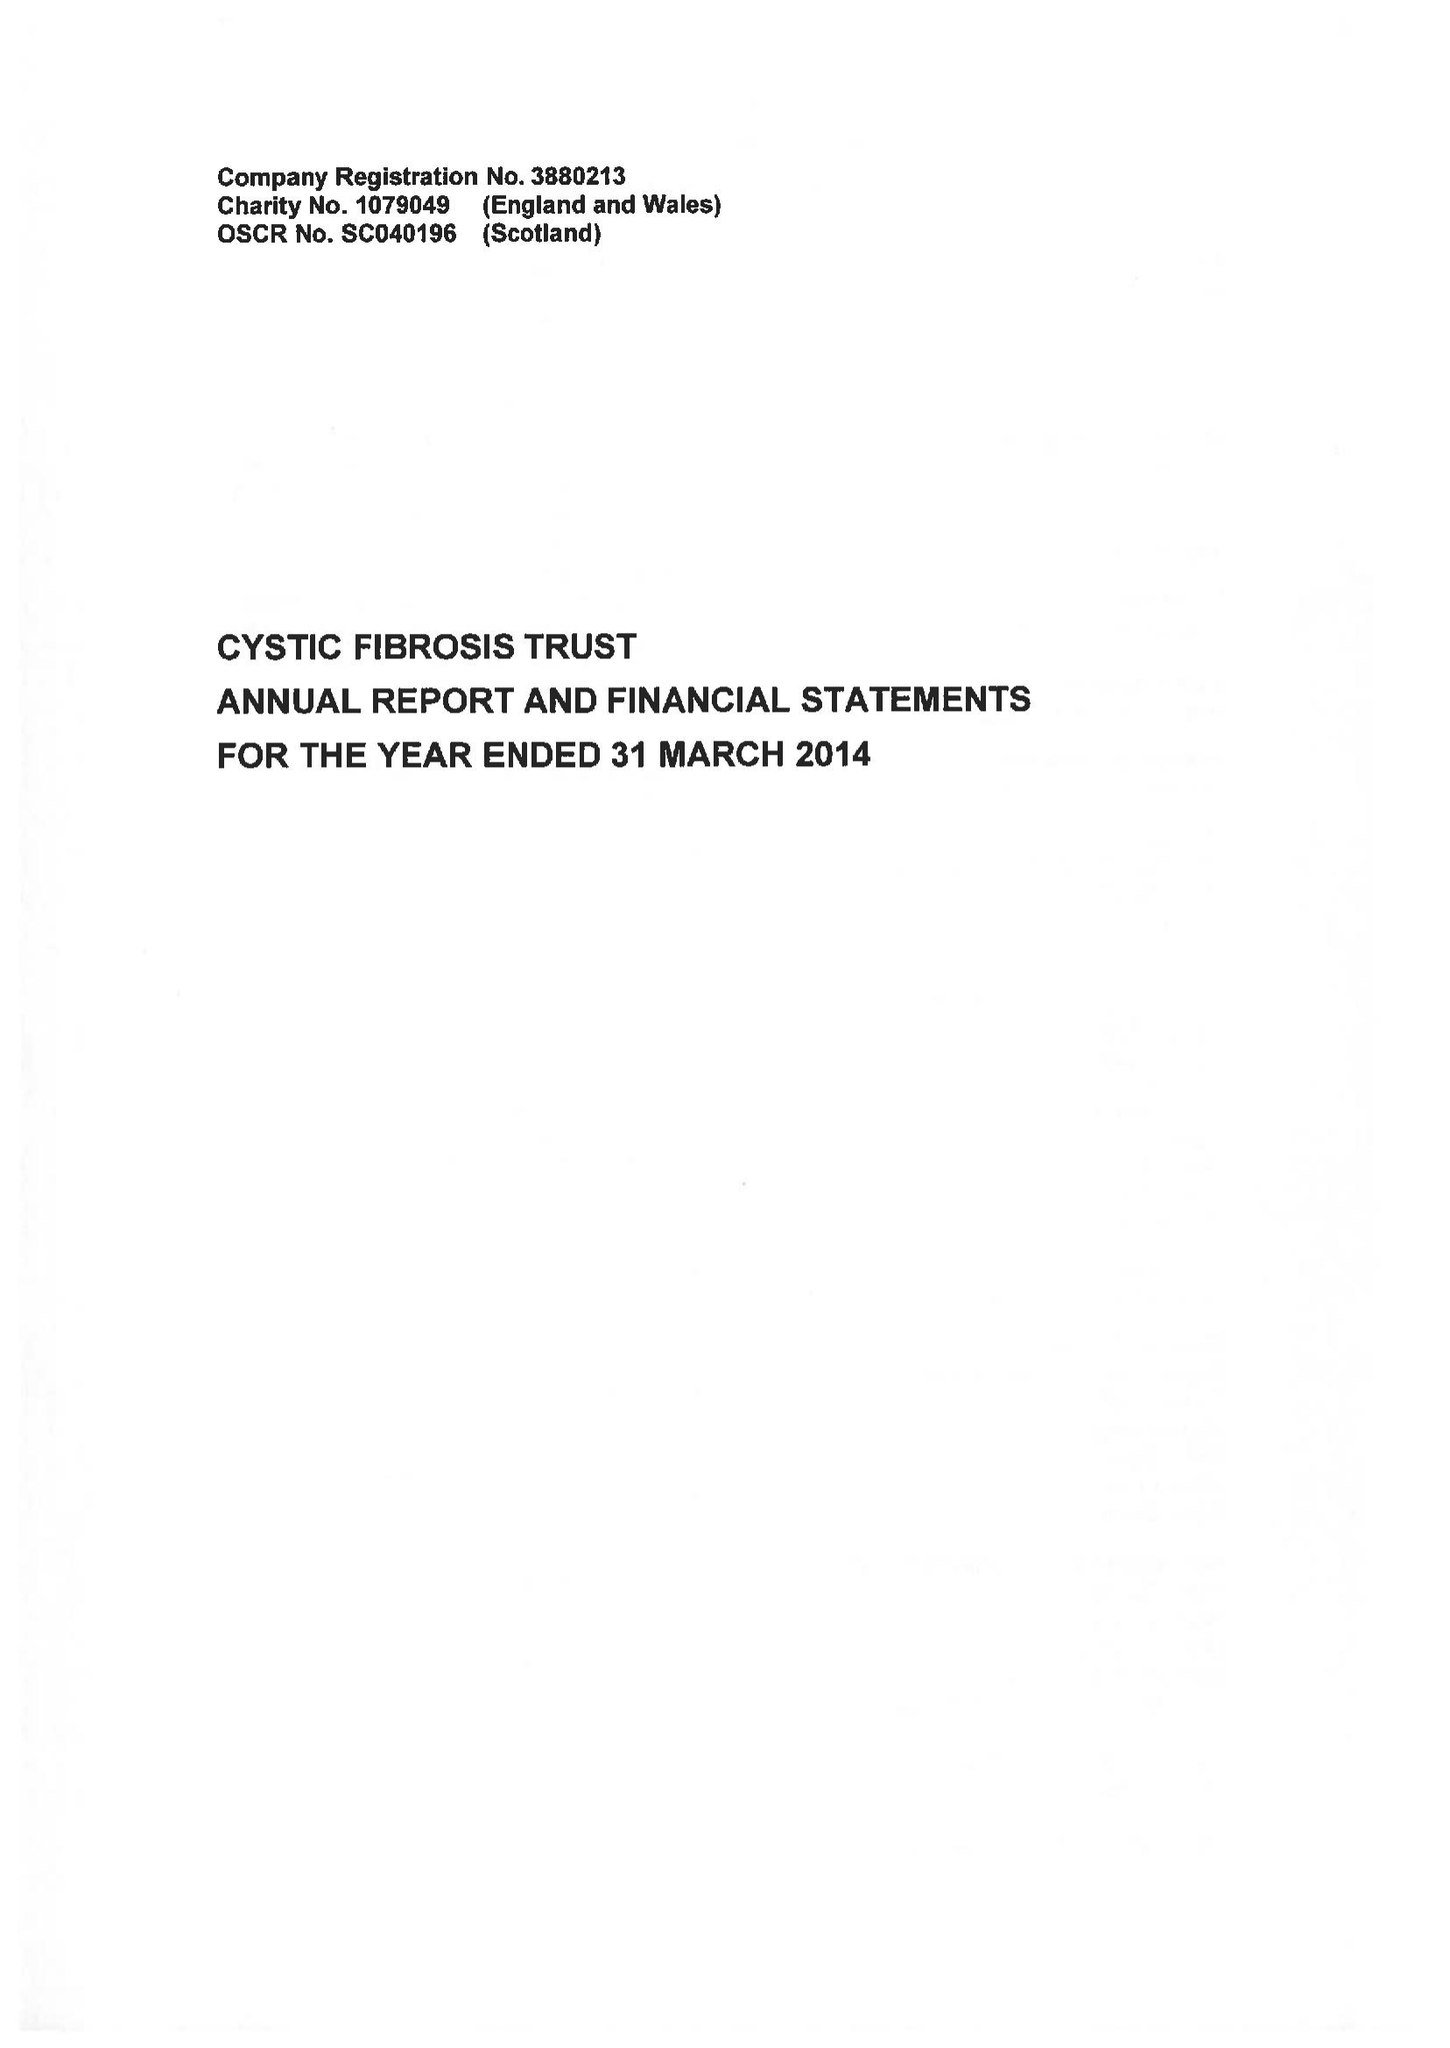What is the value for the charity_number?
Answer the question using a single word or phrase. 1079049 